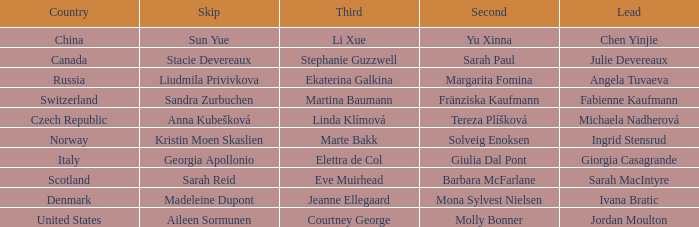What skip has martina baumann as the third? Sandra Zurbuchen. 